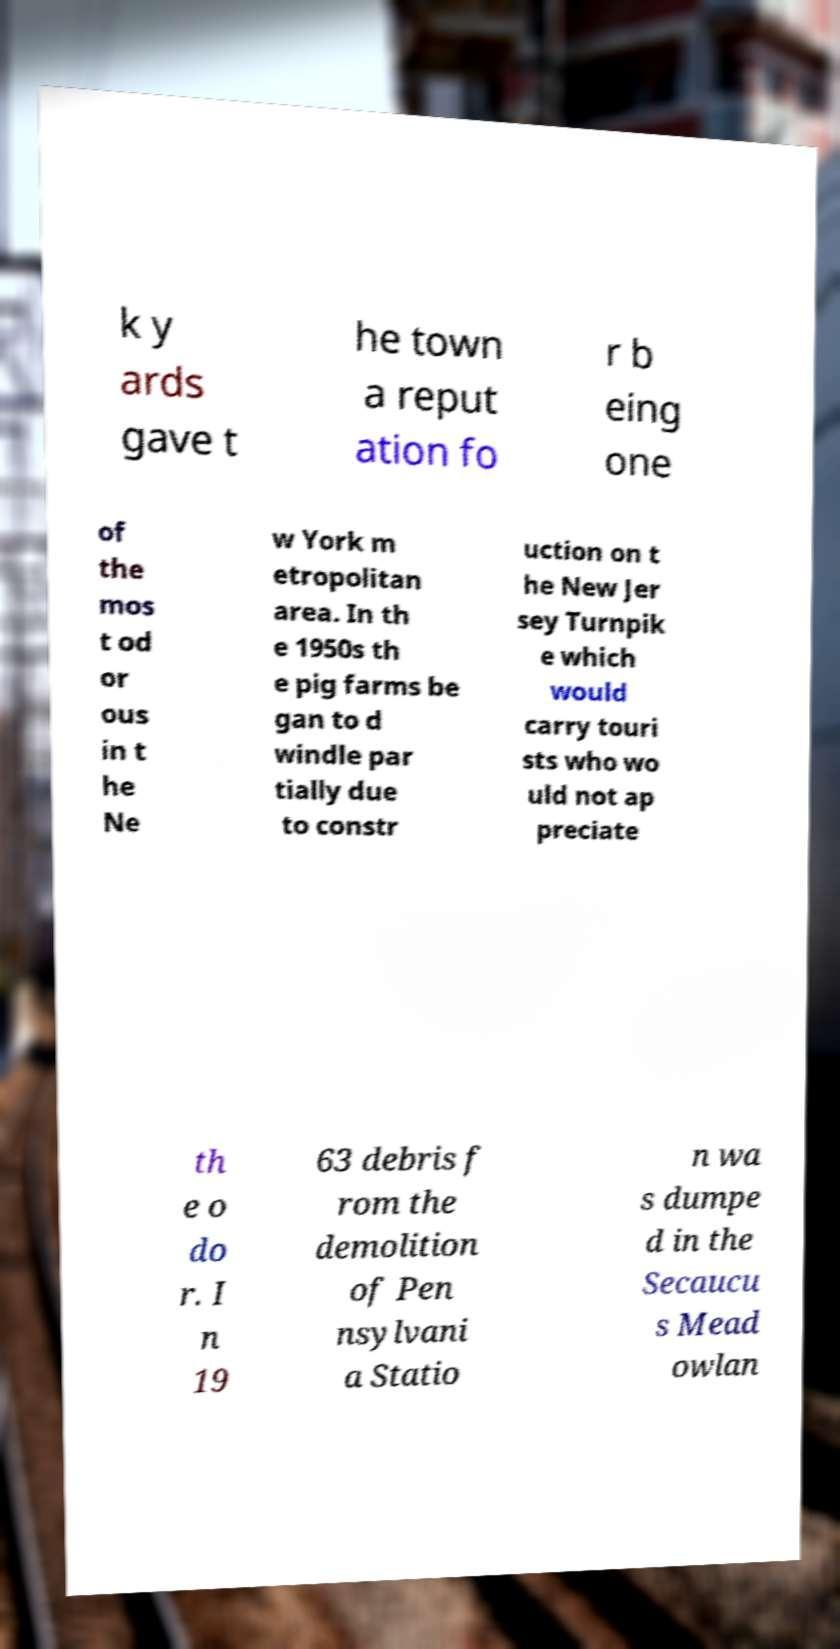Could you extract and type out the text from this image? k y ards gave t he town a reput ation fo r b eing one of the mos t od or ous in t he Ne w York m etropolitan area. In th e 1950s th e pig farms be gan to d windle par tially due to constr uction on t he New Jer sey Turnpik e which would carry touri sts who wo uld not ap preciate th e o do r. I n 19 63 debris f rom the demolition of Pen nsylvani a Statio n wa s dumpe d in the Secaucu s Mead owlan 